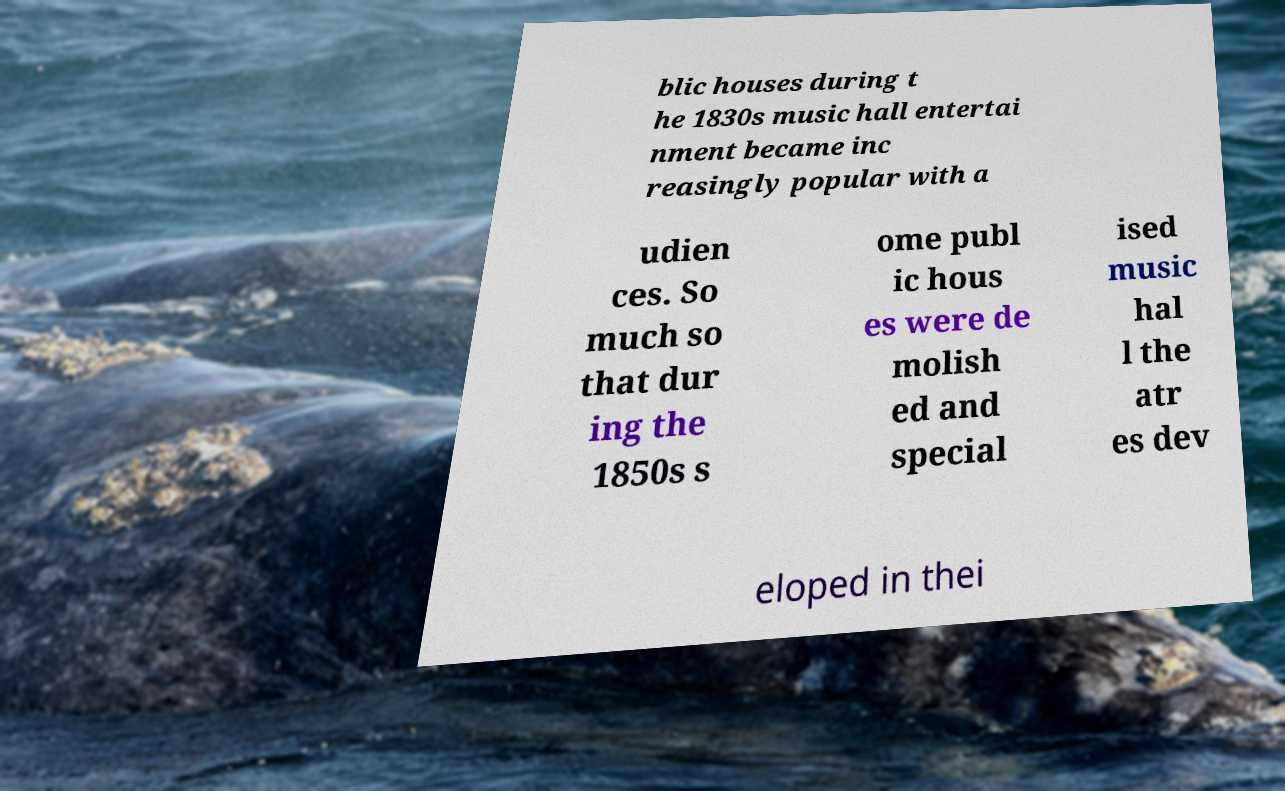What messages or text are displayed in this image? I need them in a readable, typed format. blic houses during t he 1830s music hall entertai nment became inc reasingly popular with a udien ces. So much so that dur ing the 1850s s ome publ ic hous es were de molish ed and special ised music hal l the atr es dev eloped in thei 